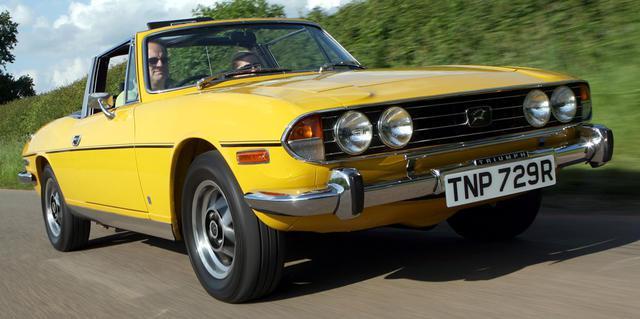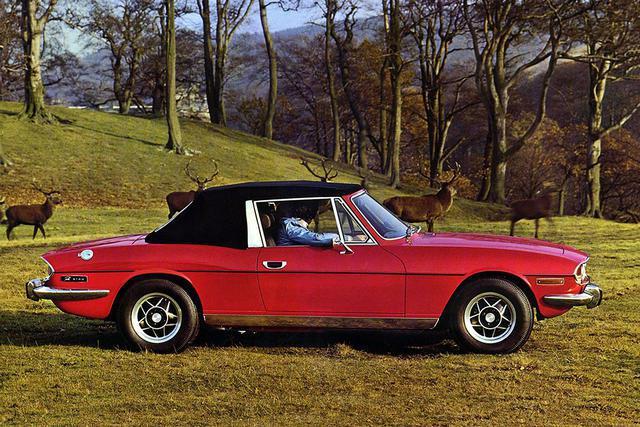The first image is the image on the left, the second image is the image on the right. Analyze the images presented: Is the assertion "There are two yellow cars parked on grass." valid? Answer yes or no. No. The first image is the image on the left, the second image is the image on the right. For the images displayed, is the sentence "An image shows a horizontal parked red convertible with its black top covering it." factually correct? Answer yes or no. Yes. 